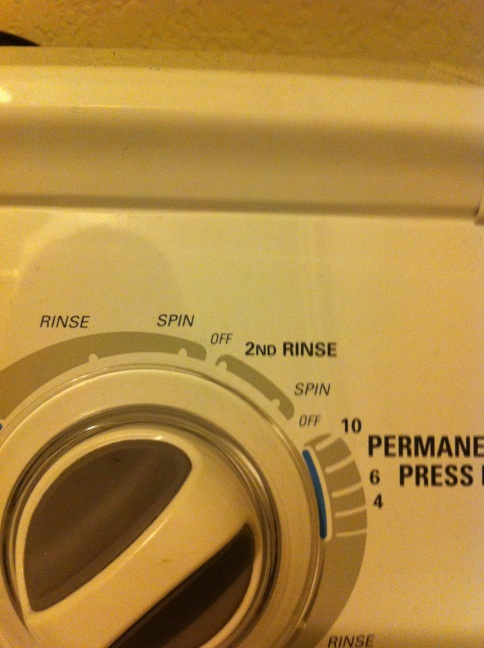What is the benefit of the '2nd Rinse' feature on this washer? The '2nd Rinse' feature is beneficial because it provides an extra rinse cycle, which can be particularly useful for people with sensitive skin who need to ensure all detergent is thoroughly removed from their clothes. It can also help with very soiled clothes that may require additional rinsing to remove all the dirt and detergent effectively. 